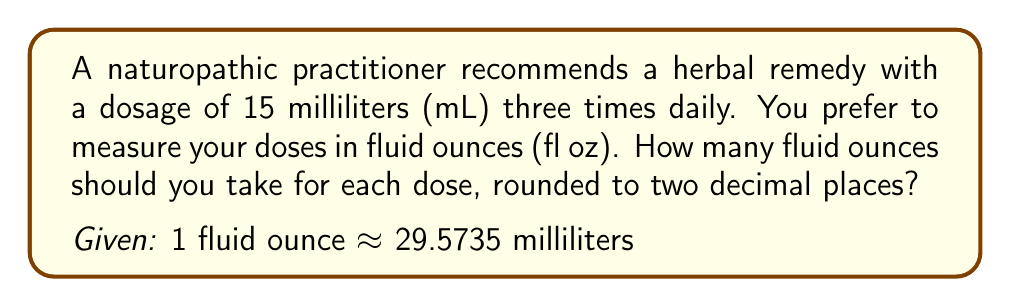Teach me how to tackle this problem. To convert the dosage from milliliters to fluid ounces, we need to divide the given volume in milliliters by the conversion factor:

1. Set up the conversion ratio:
   $$ \frac{15 \text{ mL}}{x \text{ fl oz}} = \frac{29.5735 \text{ mL}}{1 \text{ fl oz}} $$

2. Cross multiply:
   $$ 15 \cdot 1 = 29.5735x $$

3. Solve for x:
   $$ x = \frac{15}{29.5735} $$

4. Calculate the result:
   $$ x \approx 0.5072 \text{ fl oz} $$

5. Round to two decimal places:
   $$ x \approx 0.51 \text{ fl oz} $$

Therefore, each dose of 15 mL is equivalent to approximately 0.51 fluid ounces.
Answer: 0.51 fl oz 